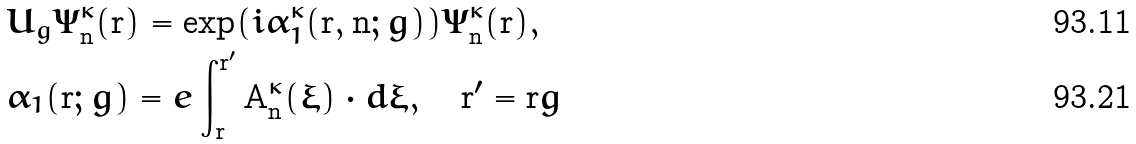Convert formula to latex. <formula><loc_0><loc_0><loc_500><loc_500>& U _ { g } \Psi ^ { \kappa } _ { \mathbf n } ( \mathbf r ) = \exp ( i \alpha ^ { \kappa } _ { 1 } ( \mathbf r , \mathbf n ; g ) ) \Psi ^ { \kappa } _ { \mathbf n } ( \mathbf r ) , \\ & \alpha _ { 1 } ( \mathbf r ; g ) = e \int _ { \mathbf r } ^ { \mathbf r ^ { \prime } } \mathbf A ^ { \kappa } _ { \mathbf n } ( \boldsymbol \xi ) \cdot d \boldsymbol \xi , \quad \mathbf r ^ { \prime } = \mathbf r g</formula> 